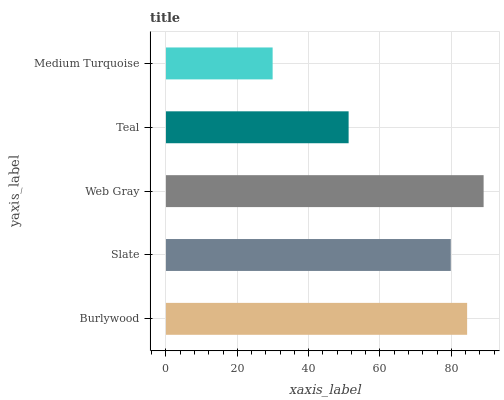Is Medium Turquoise the minimum?
Answer yes or no. Yes. Is Web Gray the maximum?
Answer yes or no. Yes. Is Slate the minimum?
Answer yes or no. No. Is Slate the maximum?
Answer yes or no. No. Is Burlywood greater than Slate?
Answer yes or no. Yes. Is Slate less than Burlywood?
Answer yes or no. Yes. Is Slate greater than Burlywood?
Answer yes or no. No. Is Burlywood less than Slate?
Answer yes or no. No. Is Slate the high median?
Answer yes or no. Yes. Is Slate the low median?
Answer yes or no. Yes. Is Web Gray the high median?
Answer yes or no. No. Is Teal the low median?
Answer yes or no. No. 